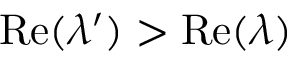Convert formula to latex. <formula><loc_0><loc_0><loc_500><loc_500>R e ( \lambda ^ { \prime } ) > R e ( \lambda )</formula> 